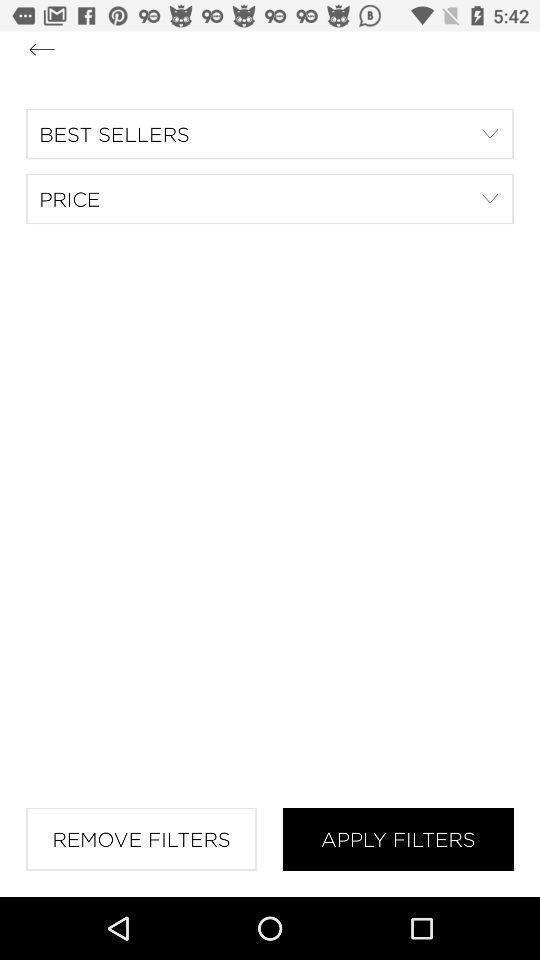Provide a textual representation of this image. Page showing options for applying filters. 